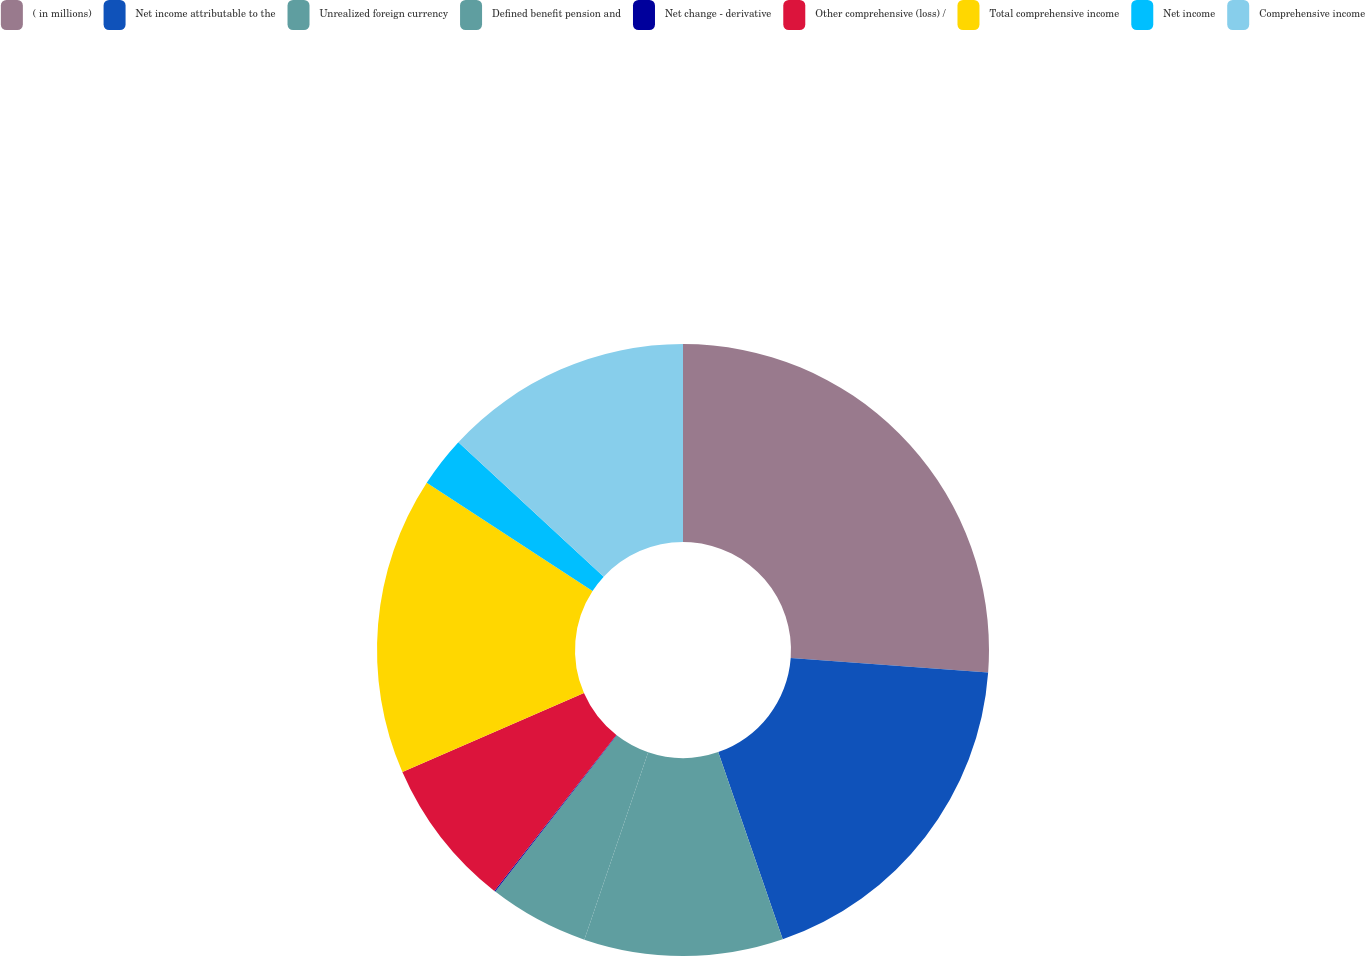<chart> <loc_0><loc_0><loc_500><loc_500><pie_chart><fcel>( in millions)<fcel>Net income attributable to the<fcel>Unrealized foreign currency<fcel>Defined benefit pension and<fcel>Net change - derivative<fcel>Other comprehensive (loss) /<fcel>Total comprehensive income<fcel>Net income<fcel>Comprehensive income<nl><fcel>26.18%<fcel>18.54%<fcel>10.51%<fcel>5.29%<fcel>0.06%<fcel>7.9%<fcel>15.73%<fcel>2.68%<fcel>13.12%<nl></chart> 